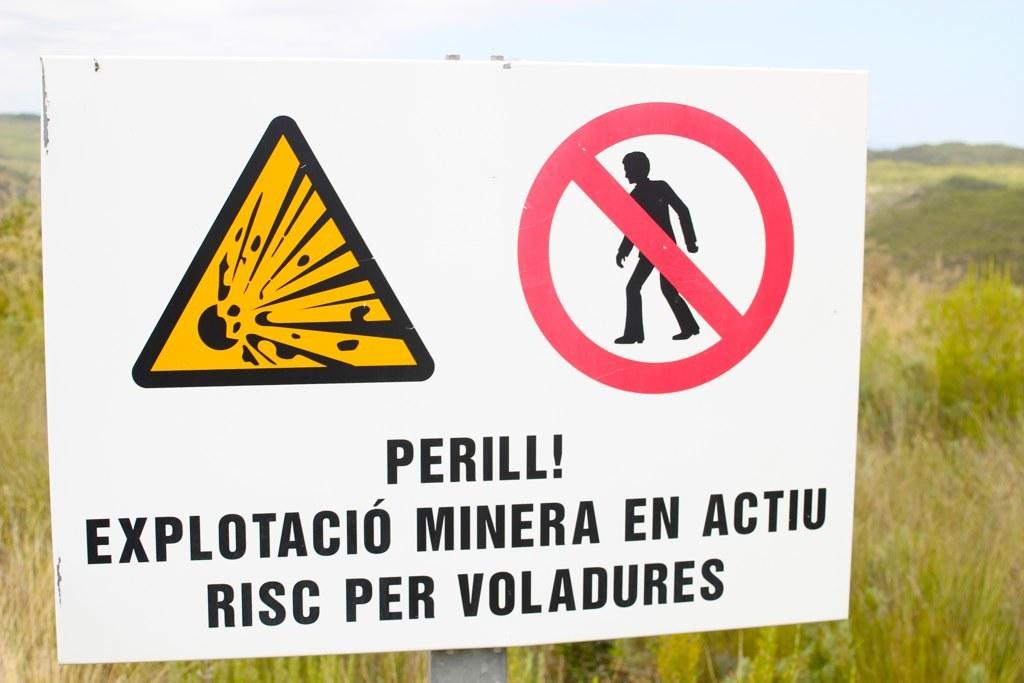<image>
Summarize the visual content of the image. A sign showing a explosive potential with "Perill!" written on it. 